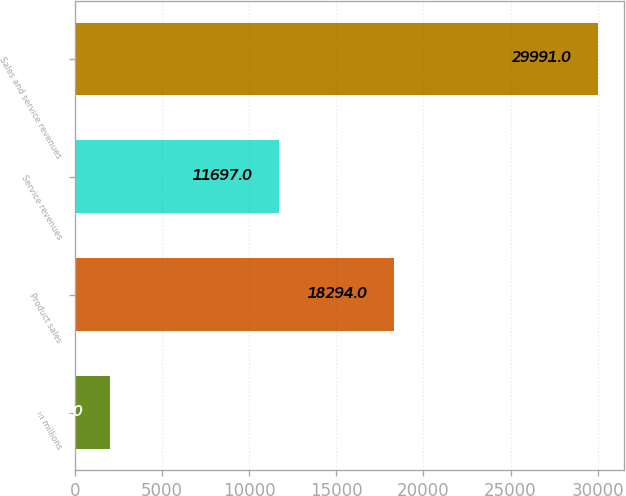Convert chart. <chart><loc_0><loc_0><loc_500><loc_500><bar_chart><fcel>in millions<fcel>Product sales<fcel>Service revenues<fcel>Sales and service revenues<nl><fcel>2006<fcel>18294<fcel>11697<fcel>29991<nl></chart> 